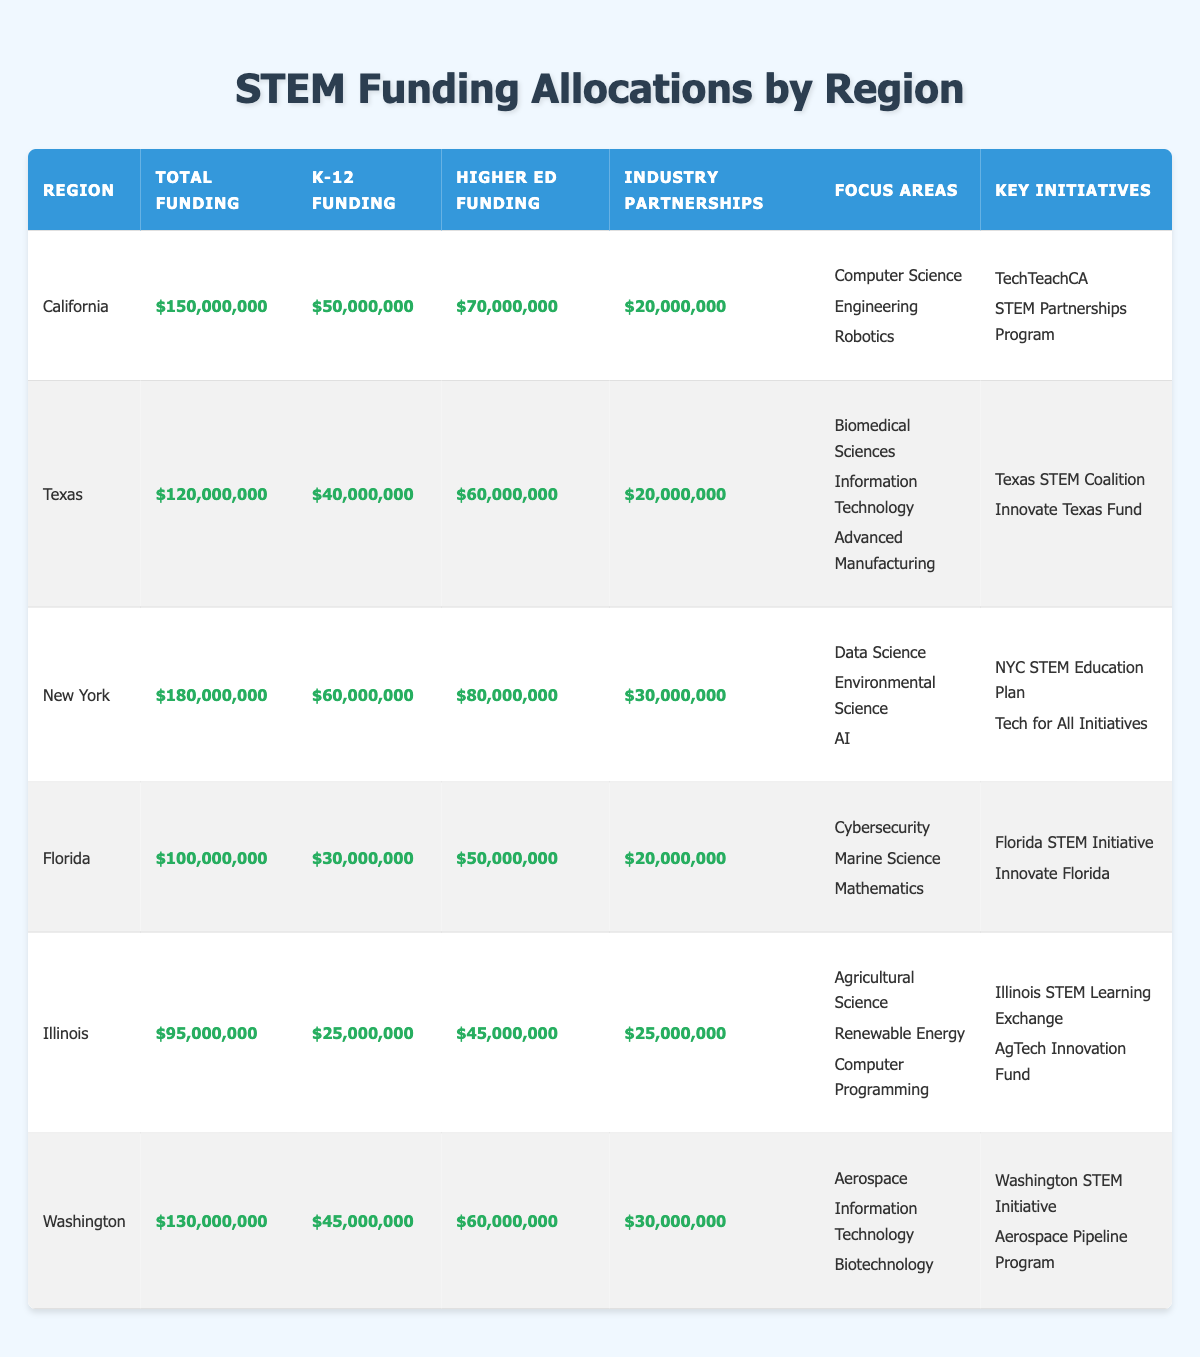What is the total funding for STEM education initiatives in New York? The total funding listed for New York in the table is $180,000,000.
Answer: $180,000,000 Which region has the highest K-12 funding? By comparing the K-12 funding values across all regions, California has the highest K-12 funding at $50,000,000.
Answer: California What is the difference in total funding between California and Texas? The total funding for California is $150,000,000, and for Texas, it is $120,000,000. Thus, the difference is $150,000,000 - $120,000,000 = $30,000,000.
Answer: $30,000,000 Is the industry partnerships funding in Illinois greater than that in Florida? The industry partnerships funding in Illinois is $25,000,000 while in Florida it is $20,000,000. Thus, $25,000,000 > $20,000,000 is true.
Answer: Yes What is the average higher education funding across all regions? The total higher education funding is ($70,000,000 + $60,000,000 + $80,000,000 + $50,000,000 + $45,000,000 + $60,000,000) = $365,000,000. There are 6 regions, so the average is $365,000,000 / 6 ≈ $60,833,333.
Answer: $60,833,333 Which region has the least total funding, and what is that amount? Looking at the total funding values for all regions, Illinois has the least total funding at $95,000,000.
Answer: Illinois, $95,000,000 If we sum the industry partnerships funding for New York and Washington, what is the resulting amount? The industry partnerships funding for New York is $30,000,000, and for Washington it is $30,000,000. Therefore, the total is $30,000,000 + $30,000,000 = $60,000,000.
Answer: $60,000,000 What focus area is exclusive to Illinois? The focus area for Illinois includes "Agricultural Science," which is not mentioned in the focus areas of other regions.
Answer: Agricultural Science Which region invests the most in industry partnerships? By reviewing the values in the industry partnerships column, both New York and Washington invest $30,000,000, which is the highest amount.
Answer: New York and Washington What is the total funding allocated for K-12 education across all regions? The K-12 funding is summed as follows: $50,000,000 (California) + $40,000,000 (Texas) + $60,000,000 (New York) + $30,000,000 (Florida) + $25,000,000 (Illinois) + $45,000,000 (Washington) = $250,000,000.
Answer: $250,000,000 